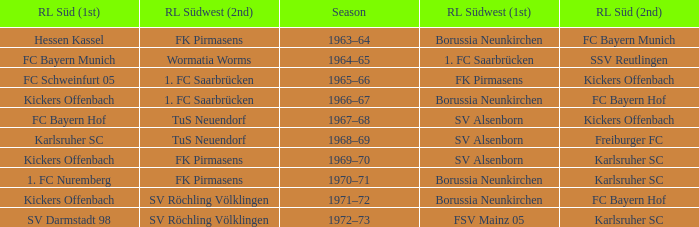Who was RL Süd (1st) when FK Pirmasens was RL Südwest (1st)? FC Schweinfurt 05. 